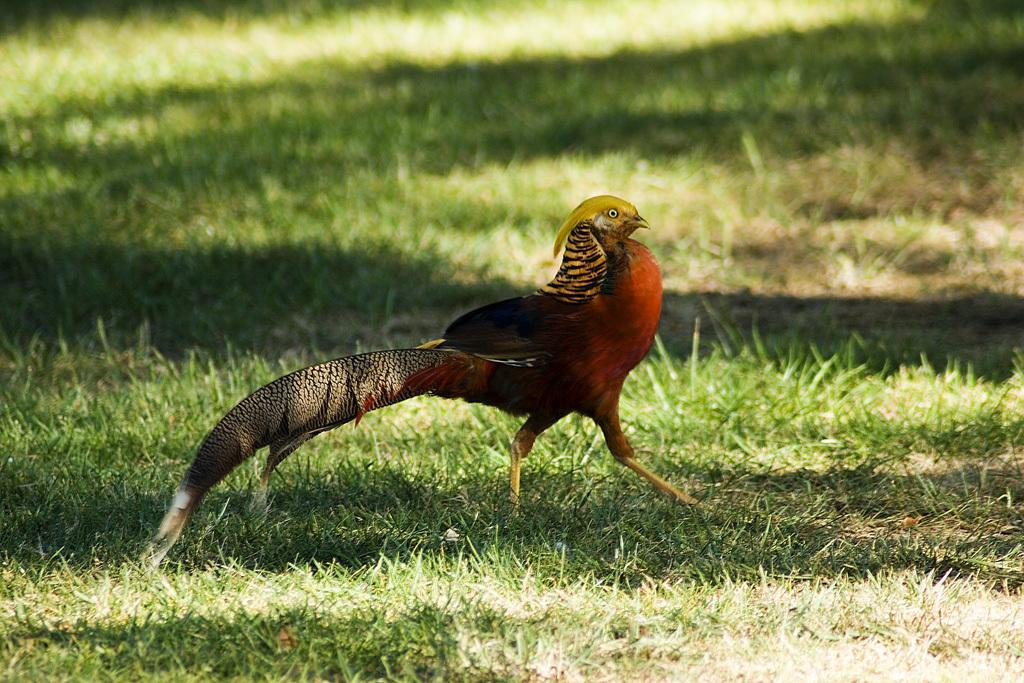Where was the image taken? The image was taken outdoors. What type of surface is visible in the image? There is a ground with grass in the image. What animal can be seen on the ground in the image? There is a bird on the ground in the image. What day of the week is depicted in the image? The image does not depict a specific day of the week; it is a still photograph. 